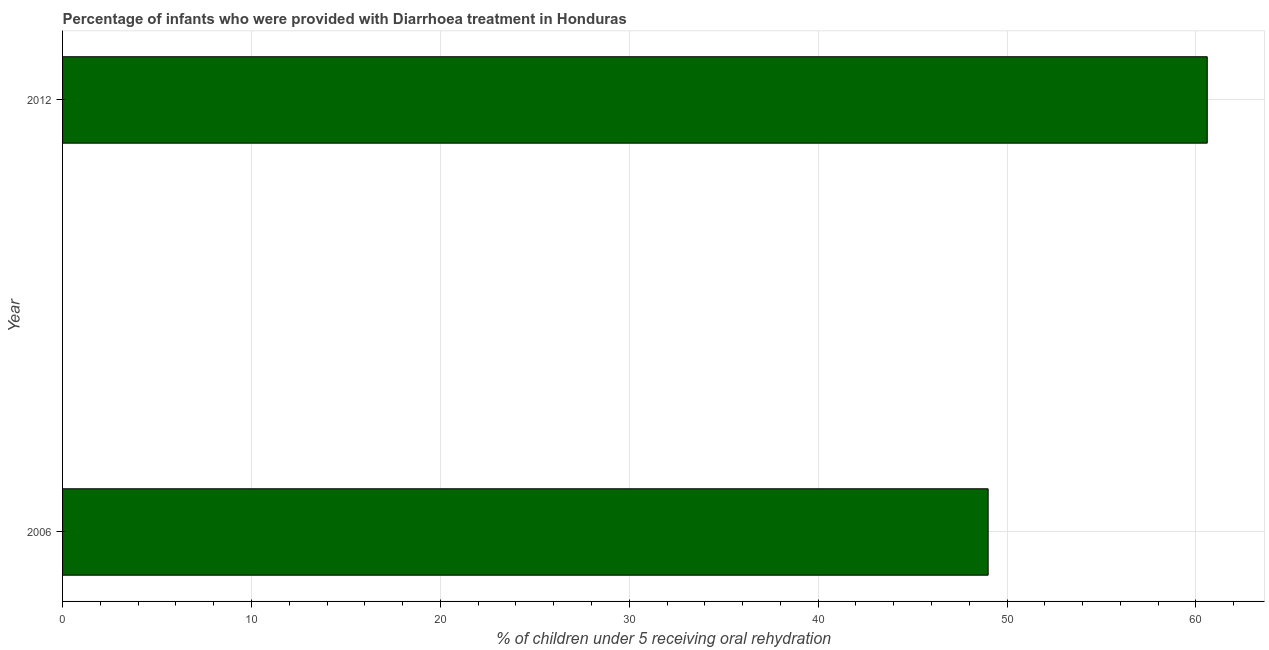Does the graph contain grids?
Provide a short and direct response. Yes. What is the title of the graph?
Give a very brief answer. Percentage of infants who were provided with Diarrhoea treatment in Honduras. What is the label or title of the X-axis?
Provide a short and direct response. % of children under 5 receiving oral rehydration. What is the label or title of the Y-axis?
Offer a very short reply. Year. What is the percentage of children who were provided with treatment diarrhoea in 2012?
Make the answer very short. 60.6. Across all years, what is the maximum percentage of children who were provided with treatment diarrhoea?
Keep it short and to the point. 60.6. In which year was the percentage of children who were provided with treatment diarrhoea maximum?
Provide a succinct answer. 2012. In which year was the percentage of children who were provided with treatment diarrhoea minimum?
Offer a terse response. 2006. What is the sum of the percentage of children who were provided with treatment diarrhoea?
Your answer should be very brief. 109.6. What is the average percentage of children who were provided with treatment diarrhoea per year?
Give a very brief answer. 54.8. What is the median percentage of children who were provided with treatment diarrhoea?
Make the answer very short. 54.8. In how many years, is the percentage of children who were provided with treatment diarrhoea greater than 34 %?
Offer a very short reply. 2. What is the ratio of the percentage of children who were provided with treatment diarrhoea in 2006 to that in 2012?
Keep it short and to the point. 0.81. How many years are there in the graph?
Make the answer very short. 2. What is the difference between two consecutive major ticks on the X-axis?
Ensure brevity in your answer.  10. What is the % of children under 5 receiving oral rehydration of 2012?
Provide a short and direct response. 60.6. What is the ratio of the % of children under 5 receiving oral rehydration in 2006 to that in 2012?
Provide a short and direct response. 0.81. 